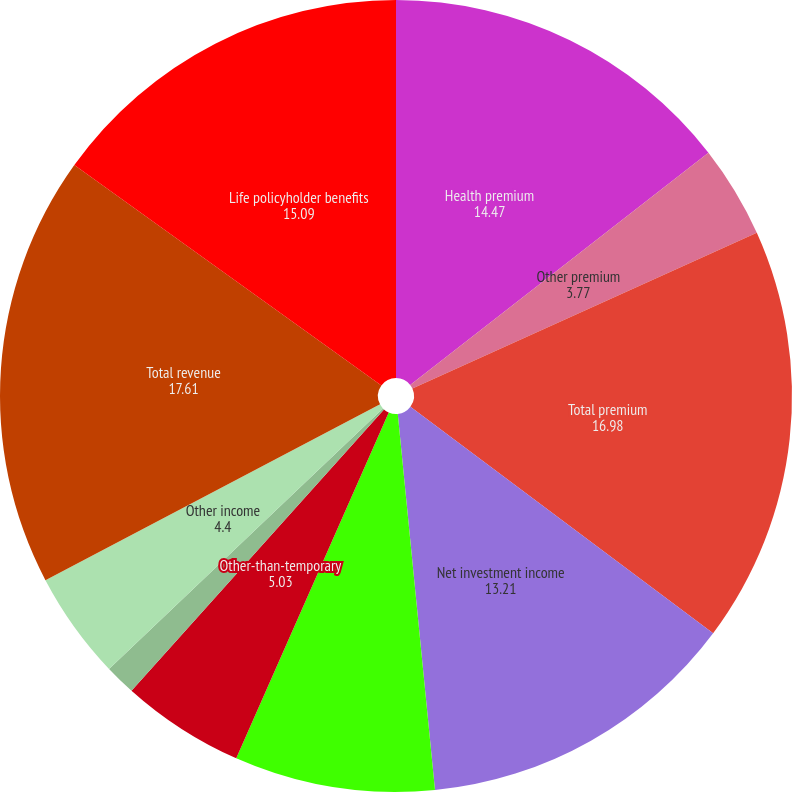<chart> <loc_0><loc_0><loc_500><loc_500><pie_chart><fcel>Health premium<fcel>Other premium<fcel>Total premium<fcel>Net investment income<fcel>Realized investment gains<fcel>Other-than-temporary<fcel>Portion of impairment loss<fcel>Other income<fcel>Total revenue<fcel>Life policyholder benefits<nl><fcel>14.47%<fcel>3.77%<fcel>16.98%<fcel>13.21%<fcel>8.18%<fcel>5.03%<fcel>1.26%<fcel>4.4%<fcel>17.61%<fcel>15.09%<nl></chart> 